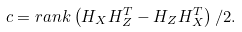Convert formula to latex. <formula><loc_0><loc_0><loc_500><loc_500>c = r a n k \left ( H _ { X } H _ { Z } ^ { T } - H _ { Z } H _ { X } ^ { T } \right ) / 2 .</formula> 